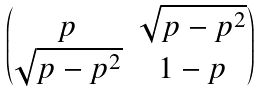Convert formula to latex. <formula><loc_0><loc_0><loc_500><loc_500>\begin{pmatrix} p & \sqrt { p - p ^ { 2 } } \\ \sqrt { p - p ^ { 2 } } & 1 - p \end{pmatrix}</formula> 